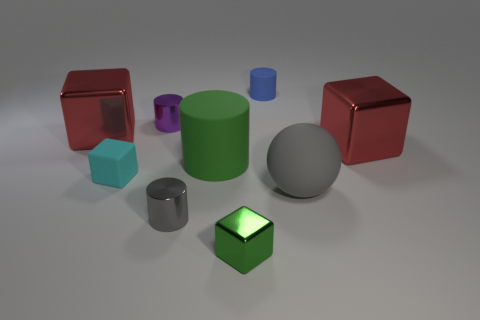Are any brown spheres visible?
Your answer should be very brief. No. There is a matte ball; is its color the same as the big cube that is right of the big ball?
Provide a succinct answer. No. What is the material of the thing that is the same color as the ball?
Offer a very short reply. Metal. Are there any other things that have the same shape as the gray metallic thing?
Provide a short and direct response. Yes. What shape is the tiny matte object behind the large red block that is to the left of the small thing to the right of the tiny green metal object?
Make the answer very short. Cylinder. What is the shape of the large gray rubber object?
Your response must be concise. Sphere. What is the color of the big metal block to the left of the tiny blue object?
Give a very brief answer. Red. There is a matte thing that is on the left side of the gray cylinder; is its size the same as the tiny blue thing?
Give a very brief answer. Yes. There is another metal thing that is the same shape as the small gray shiny object; what size is it?
Keep it short and to the point. Small. Are there any other things that are the same size as the cyan block?
Your answer should be compact. Yes. 